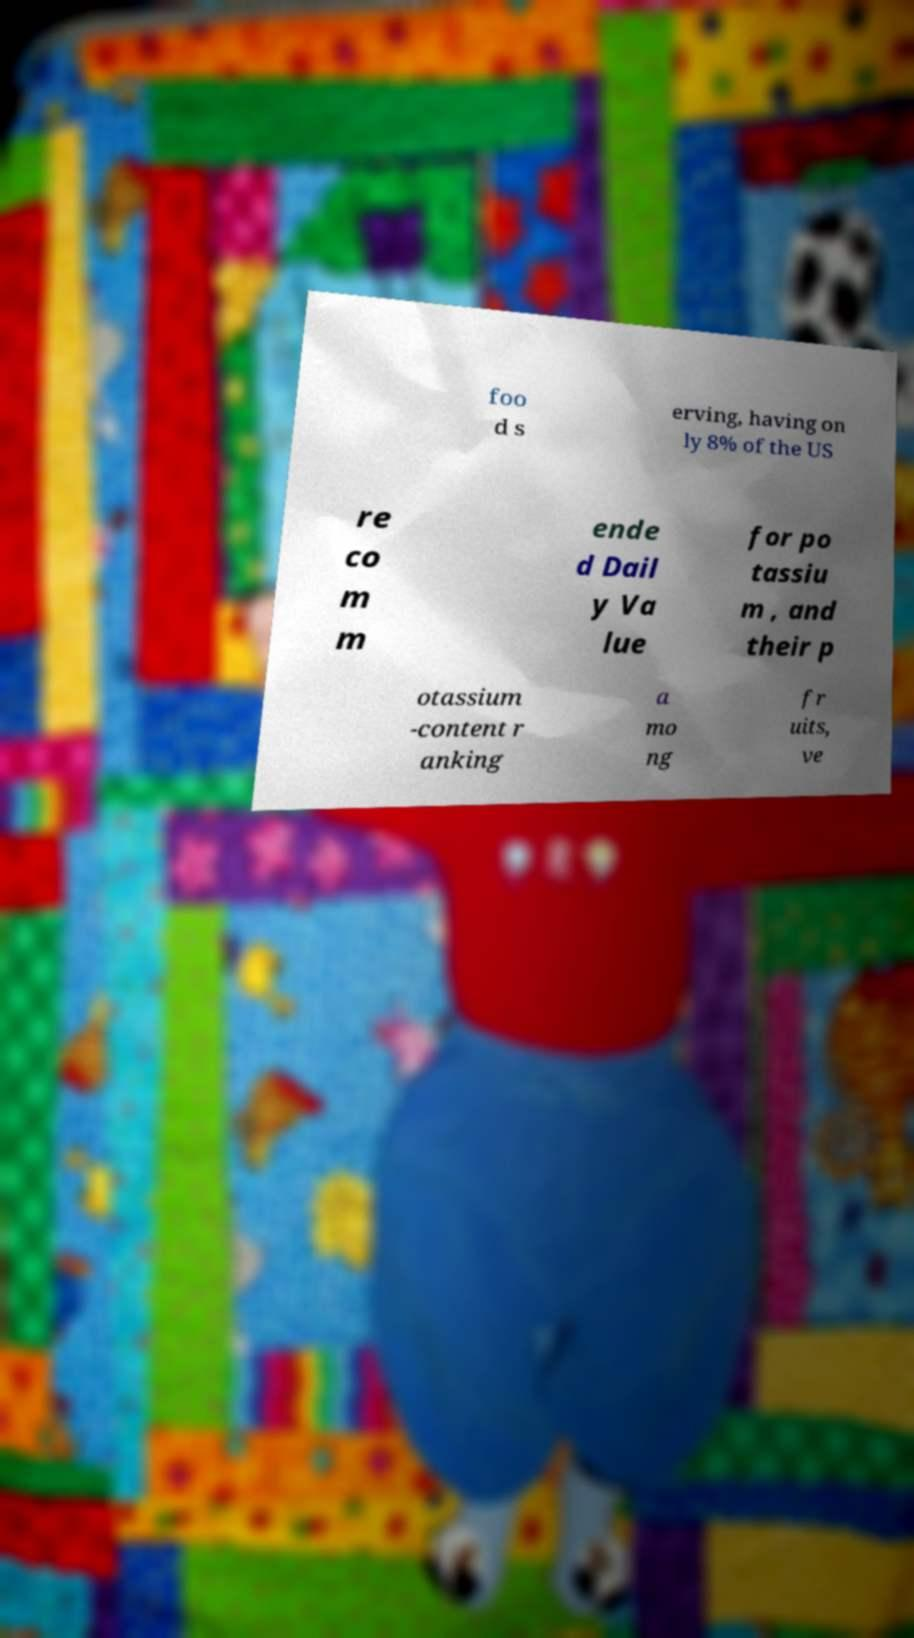Can you accurately transcribe the text from the provided image for me? foo d s erving, having on ly 8% of the US re co m m ende d Dail y Va lue for po tassiu m , and their p otassium -content r anking a mo ng fr uits, ve 